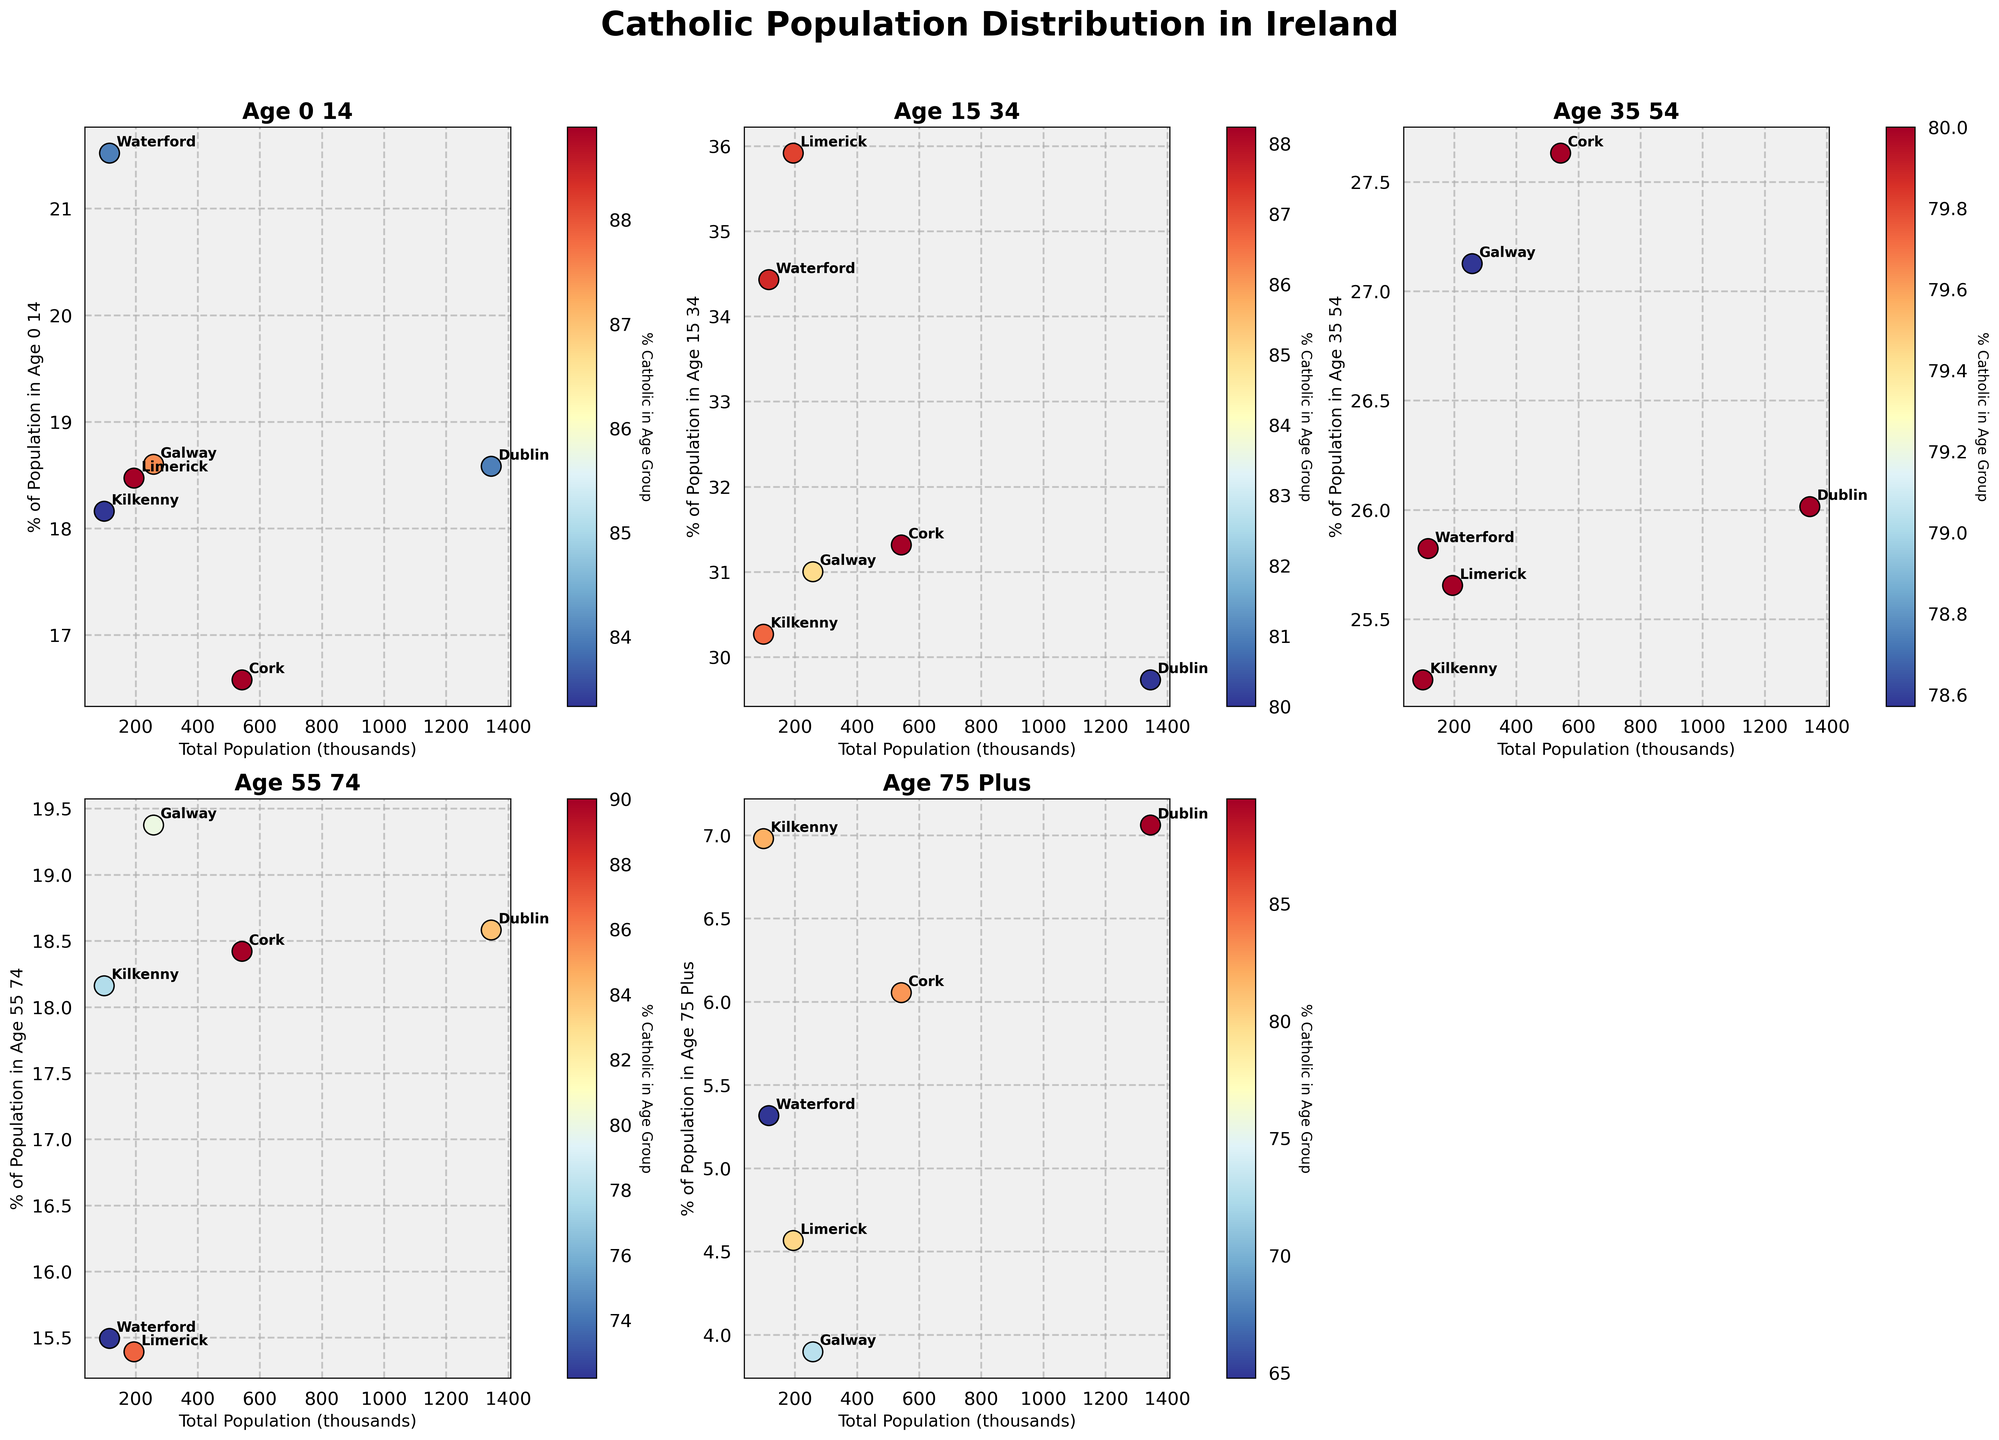What is the title of the plot? The title is found at the top of the figure and reads "Catholic Population Distribution in Ireland".
Answer: Catholic Population Distribution in Ireland Which age group subplot shows the highest percentage of Catholic population for Dublin? Find the subplot specifically showing Dublin and look at the color intensity. The deepest color in the 'Age 75 Plus' subplot indicates a high percentage.
Answer: Age 75 Plus How does the percentage of Catholic population in the 'Age 15-34' group for Cork compare to Waterford? Compare the colors of the 'Age 15-34' scatter points for Cork and Waterford. Cork is lighter than Waterford, indicating a lower percentage.
Answer: Lower In which age group does Kilkenny have the highest percentage of Catholic population? Look at all the subplots for Kilkenny and observe which has the darkest color. The 'Age 75 Plus' subplot shows the darkest color.
Answer: Age 75 Plus What is the percentage of Catholic population in the 'Age 0-14' group for Galway expressed as a rough estimate from the coloration? The 'Age 0-14' Galway scatter point shows a medium color, roughly estimating around 87%.
Answer: Approximately 87% Which region has the lowest percentage of Catholic population in the 'Age 35-54' group? Look for the lightest-colored region in the 'Age 35-54' subplot. Waterford appears the lightest, indicating the lowest percentage.
Answer: Waterford Does the percentage of Catholic population in the 'Age 55-74' group for Limerick exceed that of Galway? Check the color intensity for Limerick and Galway in the 'Age 55-74' subplot. Limerick is deeper, indicating a higher percentage.
Answer: Yes What trend can be observed regarding the percentage of Catholic population and increasing age groups in Dublin? As the age groups increase, the color intensity for Dublin grows darker, indicating an increasing percentage of Catholics in older age groups.
Answer: Increasing trend 